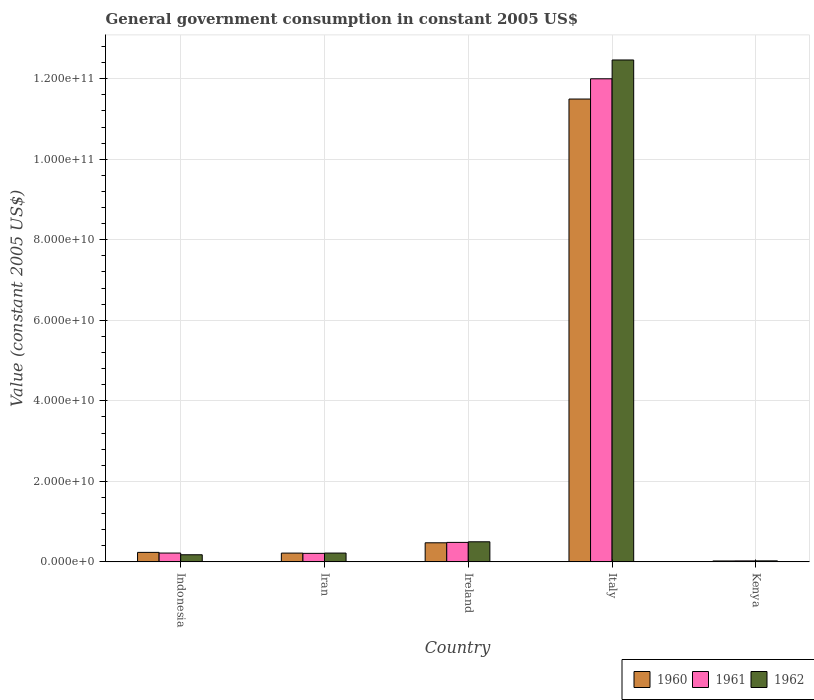How many groups of bars are there?
Your answer should be compact. 5. Are the number of bars on each tick of the X-axis equal?
Offer a very short reply. Yes. How many bars are there on the 3rd tick from the left?
Your answer should be compact. 3. How many bars are there on the 1st tick from the right?
Offer a terse response. 3. What is the government conusmption in 1960 in Italy?
Make the answer very short. 1.15e+11. Across all countries, what is the maximum government conusmption in 1961?
Keep it short and to the point. 1.20e+11. Across all countries, what is the minimum government conusmption in 1962?
Offer a very short reply. 2.50e+08. In which country was the government conusmption in 1962 minimum?
Provide a short and direct response. Kenya. What is the total government conusmption in 1962 in the graph?
Your response must be concise. 1.34e+11. What is the difference between the government conusmption in 1961 in Indonesia and that in Kenya?
Make the answer very short. 1.95e+09. What is the difference between the government conusmption in 1960 in Italy and the government conusmption in 1961 in Ireland?
Keep it short and to the point. 1.10e+11. What is the average government conusmption in 1961 per country?
Provide a succinct answer. 2.59e+1. What is the difference between the government conusmption of/in 1962 and government conusmption of/in 1961 in Iran?
Make the answer very short. 6.95e+07. In how many countries, is the government conusmption in 1962 greater than 84000000000 US$?
Offer a terse response. 1. What is the ratio of the government conusmption in 1962 in Ireland to that in Kenya?
Your answer should be very brief. 19.93. Is the government conusmption in 1961 in Italy less than that in Kenya?
Ensure brevity in your answer.  No. What is the difference between the highest and the second highest government conusmption in 1960?
Your answer should be very brief. -1.10e+11. What is the difference between the highest and the lowest government conusmption in 1962?
Your answer should be very brief. 1.24e+11. In how many countries, is the government conusmption in 1961 greater than the average government conusmption in 1961 taken over all countries?
Your answer should be very brief. 1. Is the sum of the government conusmption in 1962 in Indonesia and Kenya greater than the maximum government conusmption in 1960 across all countries?
Offer a terse response. No. What does the 3rd bar from the left in Italy represents?
Keep it short and to the point. 1962. Is it the case that in every country, the sum of the government conusmption in 1960 and government conusmption in 1962 is greater than the government conusmption in 1961?
Give a very brief answer. Yes. How many countries are there in the graph?
Provide a succinct answer. 5. Does the graph contain grids?
Keep it short and to the point. Yes. Where does the legend appear in the graph?
Ensure brevity in your answer.  Bottom right. How many legend labels are there?
Make the answer very short. 3. What is the title of the graph?
Offer a terse response. General government consumption in constant 2005 US$. What is the label or title of the X-axis?
Ensure brevity in your answer.  Country. What is the label or title of the Y-axis?
Make the answer very short. Value (constant 2005 US$). What is the Value (constant 2005 US$) of 1960 in Indonesia?
Provide a succinct answer. 2.36e+09. What is the Value (constant 2005 US$) in 1961 in Indonesia?
Your answer should be very brief. 2.19e+09. What is the Value (constant 2005 US$) of 1962 in Indonesia?
Offer a very short reply. 1.77e+09. What is the Value (constant 2005 US$) of 1960 in Iran?
Offer a terse response. 2.18e+09. What is the Value (constant 2005 US$) of 1961 in Iran?
Offer a very short reply. 2.12e+09. What is the Value (constant 2005 US$) in 1962 in Iran?
Make the answer very short. 2.19e+09. What is the Value (constant 2005 US$) in 1960 in Ireland?
Give a very brief answer. 4.74e+09. What is the Value (constant 2005 US$) in 1961 in Ireland?
Provide a short and direct response. 4.84e+09. What is the Value (constant 2005 US$) in 1962 in Ireland?
Offer a terse response. 4.99e+09. What is the Value (constant 2005 US$) in 1960 in Italy?
Your response must be concise. 1.15e+11. What is the Value (constant 2005 US$) of 1961 in Italy?
Make the answer very short. 1.20e+11. What is the Value (constant 2005 US$) in 1962 in Italy?
Your response must be concise. 1.25e+11. What is the Value (constant 2005 US$) in 1960 in Kenya?
Provide a short and direct response. 2.28e+08. What is the Value (constant 2005 US$) of 1961 in Kenya?
Offer a very short reply. 2.44e+08. What is the Value (constant 2005 US$) of 1962 in Kenya?
Provide a short and direct response. 2.50e+08. Across all countries, what is the maximum Value (constant 2005 US$) in 1960?
Give a very brief answer. 1.15e+11. Across all countries, what is the maximum Value (constant 2005 US$) in 1961?
Your answer should be very brief. 1.20e+11. Across all countries, what is the maximum Value (constant 2005 US$) in 1962?
Your answer should be compact. 1.25e+11. Across all countries, what is the minimum Value (constant 2005 US$) of 1960?
Ensure brevity in your answer.  2.28e+08. Across all countries, what is the minimum Value (constant 2005 US$) in 1961?
Your answer should be very brief. 2.44e+08. Across all countries, what is the minimum Value (constant 2005 US$) of 1962?
Your answer should be very brief. 2.50e+08. What is the total Value (constant 2005 US$) of 1960 in the graph?
Your answer should be compact. 1.24e+11. What is the total Value (constant 2005 US$) in 1961 in the graph?
Keep it short and to the point. 1.29e+11. What is the total Value (constant 2005 US$) in 1962 in the graph?
Provide a short and direct response. 1.34e+11. What is the difference between the Value (constant 2005 US$) of 1960 in Indonesia and that in Iran?
Your answer should be compact. 1.79e+08. What is the difference between the Value (constant 2005 US$) of 1961 in Indonesia and that in Iran?
Give a very brief answer. 7.22e+07. What is the difference between the Value (constant 2005 US$) of 1962 in Indonesia and that in Iran?
Provide a succinct answer. -4.19e+08. What is the difference between the Value (constant 2005 US$) in 1960 in Indonesia and that in Ireland?
Offer a terse response. -2.38e+09. What is the difference between the Value (constant 2005 US$) of 1961 in Indonesia and that in Ireland?
Provide a short and direct response. -2.65e+09. What is the difference between the Value (constant 2005 US$) in 1962 in Indonesia and that in Ireland?
Your response must be concise. -3.22e+09. What is the difference between the Value (constant 2005 US$) in 1960 in Indonesia and that in Italy?
Give a very brief answer. -1.13e+11. What is the difference between the Value (constant 2005 US$) in 1961 in Indonesia and that in Italy?
Your answer should be very brief. -1.18e+11. What is the difference between the Value (constant 2005 US$) in 1962 in Indonesia and that in Italy?
Provide a succinct answer. -1.23e+11. What is the difference between the Value (constant 2005 US$) in 1960 in Indonesia and that in Kenya?
Your answer should be compact. 2.13e+09. What is the difference between the Value (constant 2005 US$) of 1961 in Indonesia and that in Kenya?
Give a very brief answer. 1.95e+09. What is the difference between the Value (constant 2005 US$) in 1962 in Indonesia and that in Kenya?
Provide a short and direct response. 1.52e+09. What is the difference between the Value (constant 2005 US$) in 1960 in Iran and that in Ireland?
Provide a short and direct response. -2.56e+09. What is the difference between the Value (constant 2005 US$) of 1961 in Iran and that in Ireland?
Offer a very short reply. -2.72e+09. What is the difference between the Value (constant 2005 US$) of 1962 in Iran and that in Ireland?
Provide a succinct answer. -2.80e+09. What is the difference between the Value (constant 2005 US$) of 1960 in Iran and that in Italy?
Keep it short and to the point. -1.13e+11. What is the difference between the Value (constant 2005 US$) of 1961 in Iran and that in Italy?
Provide a short and direct response. -1.18e+11. What is the difference between the Value (constant 2005 US$) in 1962 in Iran and that in Italy?
Offer a very short reply. -1.22e+11. What is the difference between the Value (constant 2005 US$) in 1960 in Iran and that in Kenya?
Give a very brief answer. 1.95e+09. What is the difference between the Value (constant 2005 US$) of 1961 in Iran and that in Kenya?
Provide a short and direct response. 1.87e+09. What is the difference between the Value (constant 2005 US$) in 1962 in Iran and that in Kenya?
Your answer should be compact. 1.94e+09. What is the difference between the Value (constant 2005 US$) of 1960 in Ireland and that in Italy?
Your response must be concise. -1.10e+11. What is the difference between the Value (constant 2005 US$) of 1961 in Ireland and that in Italy?
Offer a very short reply. -1.15e+11. What is the difference between the Value (constant 2005 US$) in 1962 in Ireland and that in Italy?
Provide a succinct answer. -1.20e+11. What is the difference between the Value (constant 2005 US$) of 1960 in Ireland and that in Kenya?
Ensure brevity in your answer.  4.51e+09. What is the difference between the Value (constant 2005 US$) of 1961 in Ireland and that in Kenya?
Offer a very short reply. 4.60e+09. What is the difference between the Value (constant 2005 US$) of 1962 in Ireland and that in Kenya?
Offer a terse response. 4.74e+09. What is the difference between the Value (constant 2005 US$) in 1960 in Italy and that in Kenya?
Keep it short and to the point. 1.15e+11. What is the difference between the Value (constant 2005 US$) in 1961 in Italy and that in Kenya?
Provide a short and direct response. 1.20e+11. What is the difference between the Value (constant 2005 US$) in 1962 in Italy and that in Kenya?
Offer a very short reply. 1.24e+11. What is the difference between the Value (constant 2005 US$) of 1960 in Indonesia and the Value (constant 2005 US$) of 1961 in Iran?
Offer a very short reply. 2.41e+08. What is the difference between the Value (constant 2005 US$) of 1960 in Indonesia and the Value (constant 2005 US$) of 1962 in Iran?
Offer a terse response. 1.72e+08. What is the difference between the Value (constant 2005 US$) of 1961 in Indonesia and the Value (constant 2005 US$) of 1962 in Iran?
Your answer should be very brief. 2.74e+06. What is the difference between the Value (constant 2005 US$) in 1960 in Indonesia and the Value (constant 2005 US$) in 1961 in Ireland?
Your answer should be compact. -2.48e+09. What is the difference between the Value (constant 2005 US$) in 1960 in Indonesia and the Value (constant 2005 US$) in 1962 in Ireland?
Offer a terse response. -2.63e+09. What is the difference between the Value (constant 2005 US$) of 1961 in Indonesia and the Value (constant 2005 US$) of 1962 in Ireland?
Your answer should be compact. -2.80e+09. What is the difference between the Value (constant 2005 US$) in 1960 in Indonesia and the Value (constant 2005 US$) in 1961 in Italy?
Your answer should be very brief. -1.18e+11. What is the difference between the Value (constant 2005 US$) in 1960 in Indonesia and the Value (constant 2005 US$) in 1962 in Italy?
Give a very brief answer. -1.22e+11. What is the difference between the Value (constant 2005 US$) of 1961 in Indonesia and the Value (constant 2005 US$) of 1962 in Italy?
Offer a very short reply. -1.22e+11. What is the difference between the Value (constant 2005 US$) in 1960 in Indonesia and the Value (constant 2005 US$) in 1961 in Kenya?
Provide a succinct answer. 2.12e+09. What is the difference between the Value (constant 2005 US$) in 1960 in Indonesia and the Value (constant 2005 US$) in 1962 in Kenya?
Your response must be concise. 2.11e+09. What is the difference between the Value (constant 2005 US$) in 1961 in Indonesia and the Value (constant 2005 US$) in 1962 in Kenya?
Give a very brief answer. 1.94e+09. What is the difference between the Value (constant 2005 US$) in 1960 in Iran and the Value (constant 2005 US$) in 1961 in Ireland?
Ensure brevity in your answer.  -2.66e+09. What is the difference between the Value (constant 2005 US$) in 1960 in Iran and the Value (constant 2005 US$) in 1962 in Ireland?
Offer a very short reply. -2.81e+09. What is the difference between the Value (constant 2005 US$) of 1961 in Iran and the Value (constant 2005 US$) of 1962 in Ireland?
Ensure brevity in your answer.  -2.87e+09. What is the difference between the Value (constant 2005 US$) in 1960 in Iran and the Value (constant 2005 US$) in 1961 in Italy?
Your answer should be compact. -1.18e+11. What is the difference between the Value (constant 2005 US$) of 1960 in Iran and the Value (constant 2005 US$) of 1962 in Italy?
Offer a very short reply. -1.22e+11. What is the difference between the Value (constant 2005 US$) in 1961 in Iran and the Value (constant 2005 US$) in 1962 in Italy?
Your response must be concise. -1.23e+11. What is the difference between the Value (constant 2005 US$) of 1960 in Iran and the Value (constant 2005 US$) of 1961 in Kenya?
Give a very brief answer. 1.94e+09. What is the difference between the Value (constant 2005 US$) of 1960 in Iran and the Value (constant 2005 US$) of 1962 in Kenya?
Your response must be concise. 1.93e+09. What is the difference between the Value (constant 2005 US$) in 1961 in Iran and the Value (constant 2005 US$) in 1962 in Kenya?
Give a very brief answer. 1.87e+09. What is the difference between the Value (constant 2005 US$) in 1960 in Ireland and the Value (constant 2005 US$) in 1961 in Italy?
Offer a terse response. -1.15e+11. What is the difference between the Value (constant 2005 US$) of 1960 in Ireland and the Value (constant 2005 US$) of 1962 in Italy?
Provide a short and direct response. -1.20e+11. What is the difference between the Value (constant 2005 US$) of 1961 in Ireland and the Value (constant 2005 US$) of 1962 in Italy?
Your answer should be compact. -1.20e+11. What is the difference between the Value (constant 2005 US$) in 1960 in Ireland and the Value (constant 2005 US$) in 1961 in Kenya?
Offer a terse response. 4.50e+09. What is the difference between the Value (constant 2005 US$) of 1960 in Ireland and the Value (constant 2005 US$) of 1962 in Kenya?
Give a very brief answer. 4.49e+09. What is the difference between the Value (constant 2005 US$) in 1961 in Ireland and the Value (constant 2005 US$) in 1962 in Kenya?
Ensure brevity in your answer.  4.59e+09. What is the difference between the Value (constant 2005 US$) of 1960 in Italy and the Value (constant 2005 US$) of 1961 in Kenya?
Ensure brevity in your answer.  1.15e+11. What is the difference between the Value (constant 2005 US$) in 1960 in Italy and the Value (constant 2005 US$) in 1962 in Kenya?
Provide a succinct answer. 1.15e+11. What is the difference between the Value (constant 2005 US$) of 1961 in Italy and the Value (constant 2005 US$) of 1962 in Kenya?
Offer a very short reply. 1.20e+11. What is the average Value (constant 2005 US$) in 1960 per country?
Your response must be concise. 2.49e+1. What is the average Value (constant 2005 US$) in 1961 per country?
Offer a terse response. 2.59e+1. What is the average Value (constant 2005 US$) in 1962 per country?
Your answer should be compact. 2.68e+1. What is the difference between the Value (constant 2005 US$) of 1960 and Value (constant 2005 US$) of 1961 in Indonesia?
Provide a succinct answer. 1.69e+08. What is the difference between the Value (constant 2005 US$) in 1960 and Value (constant 2005 US$) in 1962 in Indonesia?
Your answer should be compact. 5.91e+08. What is the difference between the Value (constant 2005 US$) in 1961 and Value (constant 2005 US$) in 1962 in Indonesia?
Keep it short and to the point. 4.22e+08. What is the difference between the Value (constant 2005 US$) of 1960 and Value (constant 2005 US$) of 1961 in Iran?
Your response must be concise. 6.20e+07. What is the difference between the Value (constant 2005 US$) of 1960 and Value (constant 2005 US$) of 1962 in Iran?
Offer a terse response. -7.44e+06. What is the difference between the Value (constant 2005 US$) of 1961 and Value (constant 2005 US$) of 1962 in Iran?
Provide a succinct answer. -6.95e+07. What is the difference between the Value (constant 2005 US$) of 1960 and Value (constant 2005 US$) of 1961 in Ireland?
Provide a succinct answer. -9.93e+07. What is the difference between the Value (constant 2005 US$) of 1960 and Value (constant 2005 US$) of 1962 in Ireland?
Make the answer very short. -2.51e+08. What is the difference between the Value (constant 2005 US$) in 1961 and Value (constant 2005 US$) in 1962 in Ireland?
Your answer should be compact. -1.51e+08. What is the difference between the Value (constant 2005 US$) in 1960 and Value (constant 2005 US$) in 1961 in Italy?
Provide a succinct answer. -5.03e+09. What is the difference between the Value (constant 2005 US$) of 1960 and Value (constant 2005 US$) of 1962 in Italy?
Offer a very short reply. -9.70e+09. What is the difference between the Value (constant 2005 US$) of 1961 and Value (constant 2005 US$) of 1962 in Italy?
Give a very brief answer. -4.67e+09. What is the difference between the Value (constant 2005 US$) in 1960 and Value (constant 2005 US$) in 1961 in Kenya?
Offer a very short reply. -1.55e+07. What is the difference between the Value (constant 2005 US$) of 1960 and Value (constant 2005 US$) of 1962 in Kenya?
Give a very brief answer. -2.21e+07. What is the difference between the Value (constant 2005 US$) in 1961 and Value (constant 2005 US$) in 1962 in Kenya?
Provide a short and direct response. -6.66e+06. What is the ratio of the Value (constant 2005 US$) of 1960 in Indonesia to that in Iran?
Your response must be concise. 1.08. What is the ratio of the Value (constant 2005 US$) in 1961 in Indonesia to that in Iran?
Your response must be concise. 1.03. What is the ratio of the Value (constant 2005 US$) of 1962 in Indonesia to that in Iran?
Ensure brevity in your answer.  0.81. What is the ratio of the Value (constant 2005 US$) of 1960 in Indonesia to that in Ireland?
Your answer should be compact. 0.5. What is the ratio of the Value (constant 2005 US$) in 1961 in Indonesia to that in Ireland?
Make the answer very short. 0.45. What is the ratio of the Value (constant 2005 US$) of 1962 in Indonesia to that in Ireland?
Provide a short and direct response. 0.35. What is the ratio of the Value (constant 2005 US$) of 1960 in Indonesia to that in Italy?
Your response must be concise. 0.02. What is the ratio of the Value (constant 2005 US$) of 1961 in Indonesia to that in Italy?
Your response must be concise. 0.02. What is the ratio of the Value (constant 2005 US$) in 1962 in Indonesia to that in Italy?
Give a very brief answer. 0.01. What is the ratio of the Value (constant 2005 US$) in 1960 in Indonesia to that in Kenya?
Keep it short and to the point. 10.33. What is the ratio of the Value (constant 2005 US$) of 1961 in Indonesia to that in Kenya?
Your answer should be very brief. 8.99. What is the ratio of the Value (constant 2005 US$) in 1962 in Indonesia to that in Kenya?
Your answer should be compact. 7.06. What is the ratio of the Value (constant 2005 US$) of 1960 in Iran to that in Ireland?
Offer a terse response. 0.46. What is the ratio of the Value (constant 2005 US$) of 1961 in Iran to that in Ireland?
Ensure brevity in your answer.  0.44. What is the ratio of the Value (constant 2005 US$) of 1962 in Iran to that in Ireland?
Your answer should be compact. 0.44. What is the ratio of the Value (constant 2005 US$) of 1960 in Iran to that in Italy?
Your answer should be compact. 0.02. What is the ratio of the Value (constant 2005 US$) in 1961 in Iran to that in Italy?
Provide a short and direct response. 0.02. What is the ratio of the Value (constant 2005 US$) in 1962 in Iran to that in Italy?
Your response must be concise. 0.02. What is the ratio of the Value (constant 2005 US$) in 1960 in Iran to that in Kenya?
Give a very brief answer. 9.55. What is the ratio of the Value (constant 2005 US$) of 1961 in Iran to that in Kenya?
Provide a succinct answer. 8.69. What is the ratio of the Value (constant 2005 US$) in 1962 in Iran to that in Kenya?
Make the answer very short. 8.74. What is the ratio of the Value (constant 2005 US$) of 1960 in Ireland to that in Italy?
Your answer should be very brief. 0.04. What is the ratio of the Value (constant 2005 US$) of 1961 in Ireland to that in Italy?
Your answer should be very brief. 0.04. What is the ratio of the Value (constant 2005 US$) of 1962 in Ireland to that in Italy?
Offer a very short reply. 0.04. What is the ratio of the Value (constant 2005 US$) of 1960 in Ireland to that in Kenya?
Your answer should be compact. 20.76. What is the ratio of the Value (constant 2005 US$) of 1961 in Ireland to that in Kenya?
Make the answer very short. 19.85. What is the ratio of the Value (constant 2005 US$) in 1962 in Ireland to that in Kenya?
Your response must be concise. 19.93. What is the ratio of the Value (constant 2005 US$) in 1960 in Italy to that in Kenya?
Keep it short and to the point. 503.61. What is the ratio of the Value (constant 2005 US$) of 1961 in Italy to that in Kenya?
Offer a terse response. 492.25. What is the ratio of the Value (constant 2005 US$) in 1962 in Italy to that in Kenya?
Keep it short and to the point. 497.82. What is the difference between the highest and the second highest Value (constant 2005 US$) in 1960?
Your answer should be very brief. 1.10e+11. What is the difference between the highest and the second highest Value (constant 2005 US$) of 1961?
Your answer should be very brief. 1.15e+11. What is the difference between the highest and the second highest Value (constant 2005 US$) of 1962?
Offer a terse response. 1.20e+11. What is the difference between the highest and the lowest Value (constant 2005 US$) of 1960?
Ensure brevity in your answer.  1.15e+11. What is the difference between the highest and the lowest Value (constant 2005 US$) in 1961?
Offer a very short reply. 1.20e+11. What is the difference between the highest and the lowest Value (constant 2005 US$) in 1962?
Ensure brevity in your answer.  1.24e+11. 